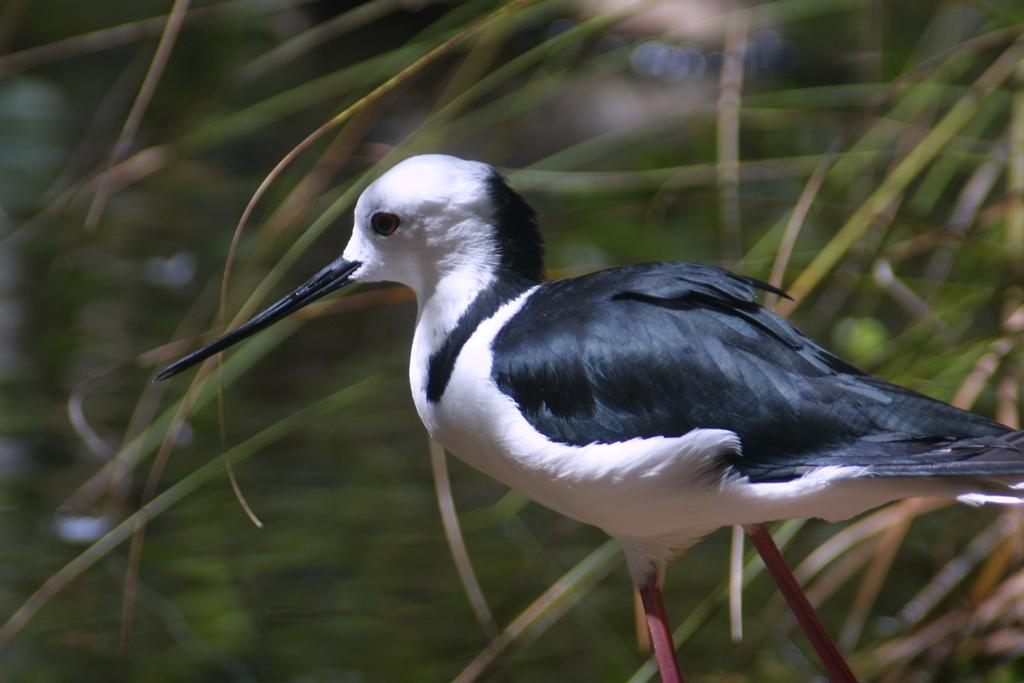What is the main subject in the center of the image? There is a bird in the center of the image. What can be seen in the background of the image? There are plants in the background of the image. Who is the judge presiding over the argument between the bird and the mitten in the image? There is no argument, judge, or mitten present in the image; it only features a bird and plants in the background. 